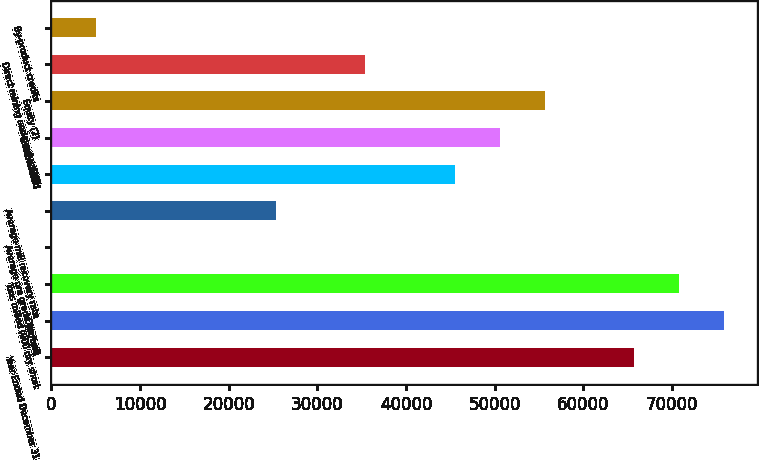<chart> <loc_0><loc_0><loc_500><loc_500><bar_chart><fcel>Year Ended December 31<fcel>Open pit<fcel>Tons milled (000 dry short<fcel>Average ore grade (oz/ton)<fcel>Average mill recovery rate<fcel>Mill<fcel>Consolidated<fcel>Equity (2)<fcel>Direct mining and production<fcel>By-product credits<nl><fcel>65737<fcel>75850.4<fcel>70793.7<fcel>0.07<fcel>25283.5<fcel>45510.3<fcel>50567<fcel>55623.7<fcel>35396.9<fcel>5056.76<nl></chart> 